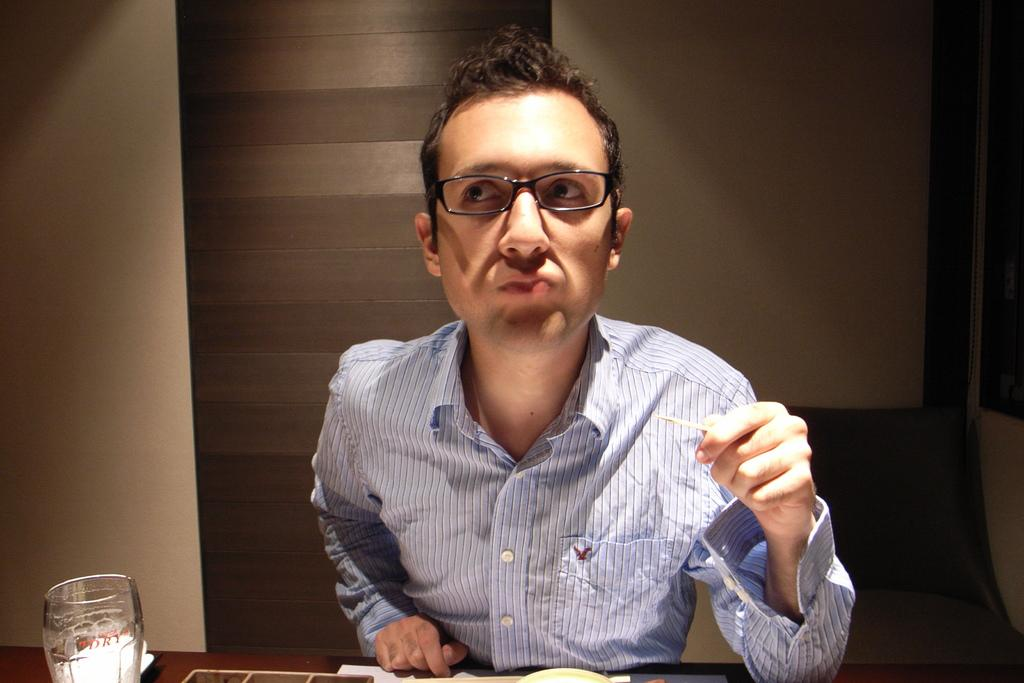What is the man in the image doing? The man is sitting in the image. What is in front of the man? There is a table in front of the man. What is placed on the table? A glass is placed on the table. What can be seen in the background of the image? There is a wall in the background of the image. What type of gun does the man have in his hobbies? There is no gun present in the image, and the man's hobbies are not mentioned. 